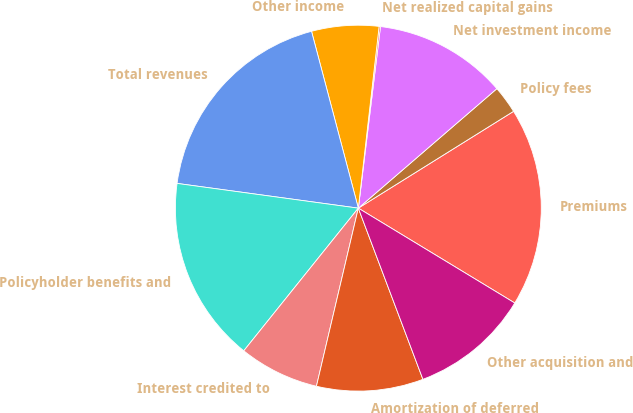Convert chart. <chart><loc_0><loc_0><loc_500><loc_500><pie_chart><fcel>Premiums<fcel>Policy fees<fcel>Net investment income<fcel>Net realized capital gains<fcel>Other income<fcel>Total revenues<fcel>Policyholder benefits and<fcel>Interest credited to<fcel>Amortization of deferred<fcel>Other acquisition and<nl><fcel>17.55%<fcel>2.45%<fcel>11.74%<fcel>0.12%<fcel>5.93%<fcel>18.72%<fcel>16.39%<fcel>7.09%<fcel>9.42%<fcel>10.58%<nl></chart> 